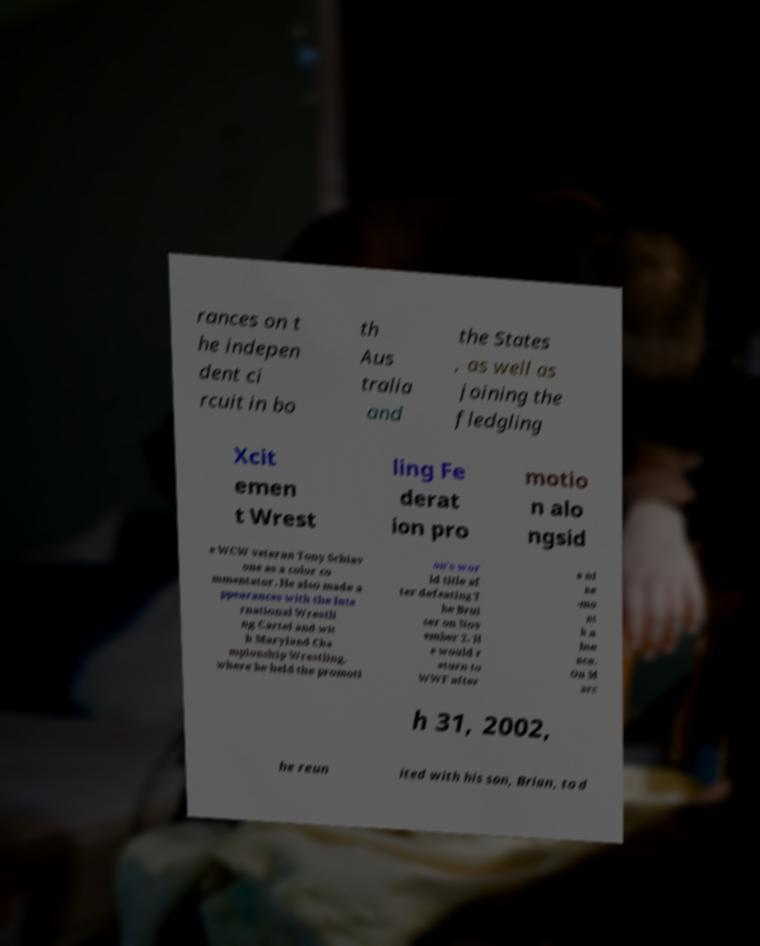Could you extract and type out the text from this image? rances on t he indepen dent ci rcuit in bo th Aus tralia and the States , as well as joining the fledgling Xcit emen t Wrest ling Fe derat ion pro motio n alo ngsid e WCW veteran Tony Schiav one as a color co mmentator. He also made a ppearances with the Inte rnational Wrestli ng Cartel and wit h Maryland Cha mpionship Wrestling, where he held the promoti on's wor ld title af ter defeating T he Brui ser on Nov ember 2. H e would r eturn to WWF after a ni ne -mo nt h a bse nce. On M arc h 31, 2002, he reun ited with his son, Brian, to d 